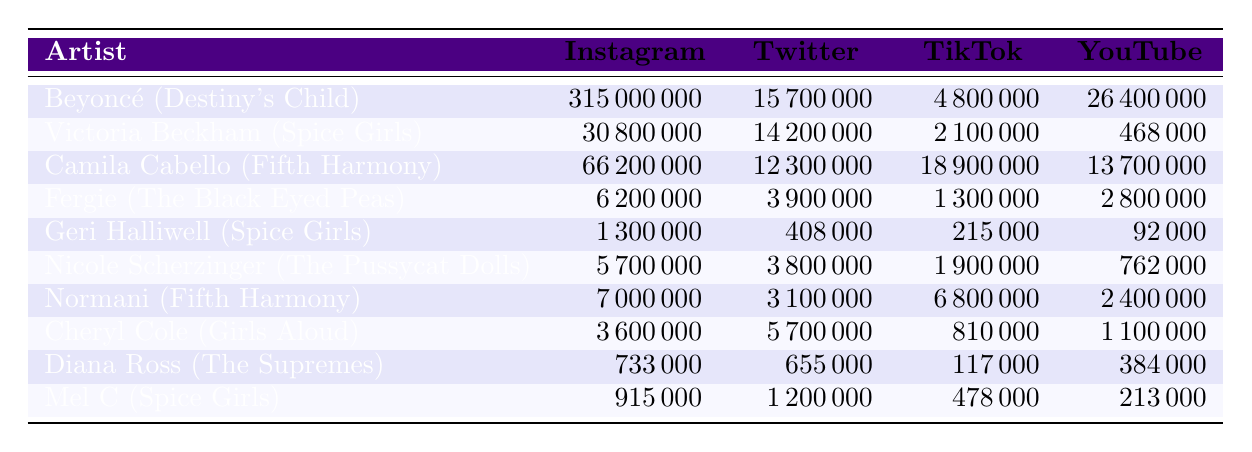What is the highest number of Instagram followers among the artists listed? By examining the Instagram follower counts in the table, the one with the highest number is Beyoncé (Destiny's Child) with 315,000,000 followers.
Answer: 315,000,000 Which artist has the lowest number of TikTok followers? Looking at the TikTok follower counts in the table, Diana Ross (The Supremes) has the lowest number with 117,000 followers.
Answer: 117,000 How many more Twitter followers does Victoria Beckham have compared to Geri Halliwell? Victoria Beckham has 14,200,000 Twitter followers, while Geri Halliwell has 408,000. The difference is 14,200,000 - 408,000 = 13,792,000.
Answer: 13,792,000 What is the total number of YouTube followers for all the artists? To get the total YouTube followers, we sum the counts: 26,400,000 + 468,000 + 13,700,000 + 2,800,000 + 92,000 + 762,000 + 2,400,000 + 1,100,000 + 384,000 + 213,000 = 47,983,000.
Answer: 47,983,000 Is it true that Camila Cabello has more TikTok followers than Normani? Camila Cabello has 18,900,000 TikTok followers, while Normani has 6,800,000. Since 18,900,000 is greater than 6,800,000, the statement is true.
Answer: Yes What is the average number of Instagram followers for the artists listed? To find the average, we first total the Instagram followers: 315,000,000 + 30,800,000 + 66,200,000 + 6,200,000 + 1,300,000 + 5,700,000 + 7,000,000 + 3,600,000 + 733,000 + 915,000 = 431,835,000. Then divide by 10 (the number of artists), giving an average of 43,183,500.
Answer: 43,183,500 Which social media platform has the highest number of followers for the members of Fifth Harmony? Checking the counts for the two Fifth Harmony artists: Camila Cabello has 66,200,000 Instagram followers, and Normani has 7,000,000. The highest number is from Camila Cabello on Instagram.
Answer: Instagram Who has the highest count for YouTube followers among the artists from Spice Girls? Comparing the YouTube followers of Spice Girls artists: Victoria Beckham has 468,000, Geri Halliwell has 92,000, and Mel C has 213,000. Victoria Beckham has the highest count at 468,000.
Answer: 468,000 How many TikTok followers do the artists from The Pussycat Dolls have in total? Since there is only one member from The Pussycat Dolls listed, Nicole Scherzinger has 1,900,000 TikTok followers, so the total is 1,900,000.
Answer: 1,900,000 Which artist has the most followers combined across all platforms? By summing the followers across all platforms for each artist, we find: Beyoncé (Destiny's Child) has the highest total with 315,000,000 + 15,700,000 + 4,800,000 + 26,400,000 = 362,900,000.
Answer: 362,900,000 